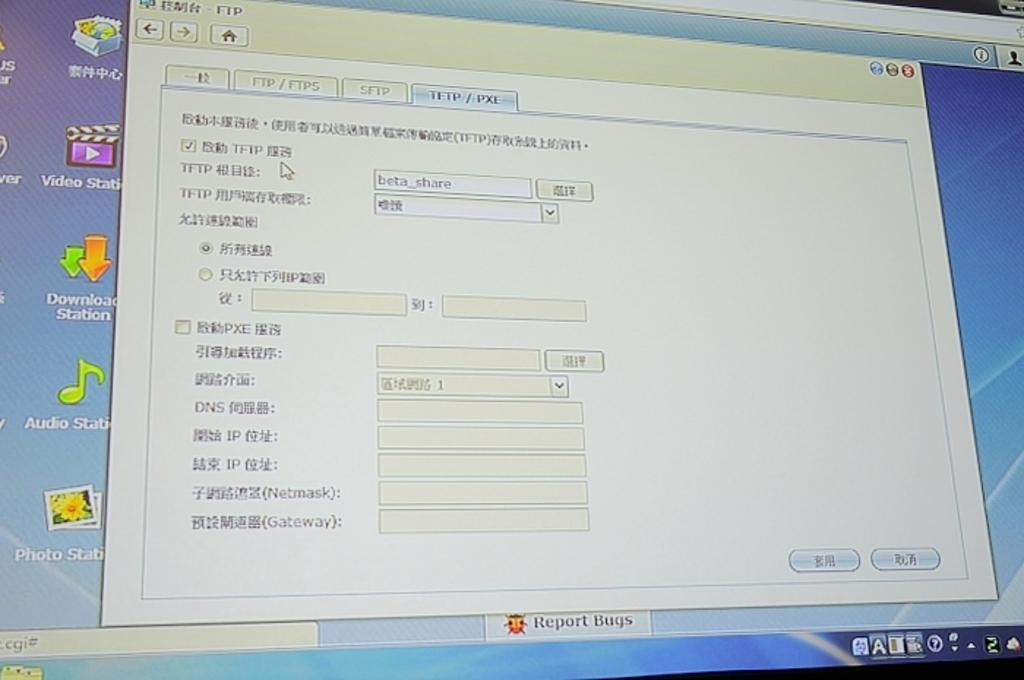<image>
Offer a succinct explanation of the picture presented. A computer screen with an FTP application opened up. 